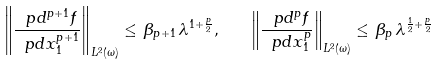<formula> <loc_0><loc_0><loc_500><loc_500>\left \| \frac { \ p d ^ { p + 1 } f } { \ p d x _ { 1 } ^ { p + 1 } } \right \| _ { L ^ { 2 } ( \omega ) } \leq \, \beta _ { p + 1 } \, \lambda ^ { 1 + \frac { p } { 2 } } , \quad \left \| \frac { \ p d ^ { p } f } { \ p d x _ { 1 } ^ { p } } \right \| _ { L ^ { 2 } ( \omega ) } \leq \, \beta _ { p } \, \lambda ^ { \frac { 1 } { 2 } + \frac { p } { 2 } }</formula> 